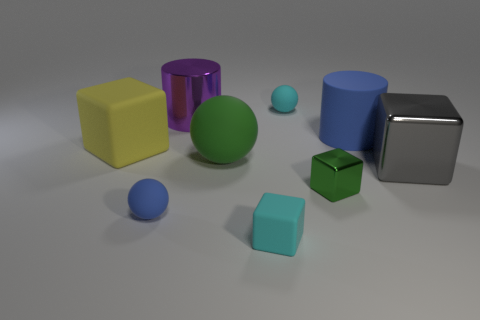There is a purple object that is the same size as the yellow matte object; what is it made of?
Your answer should be compact. Metal. Does the tiny green metal object have the same shape as the big yellow thing?
Make the answer very short. Yes. How many things are either tiny rubber spheres or small balls that are behind the green block?
Your answer should be very brief. 2. There is a block that is the same color as the large matte sphere; what is its material?
Your response must be concise. Metal. There is a cyan rubber object that is in front of the gray object; is its size the same as the large gray object?
Provide a succinct answer. No. There is a cyan rubber object in front of the large cube to the left of the big rubber cylinder; how many large yellow rubber cubes are behind it?
Provide a short and direct response. 1. What number of cyan objects are small matte objects or balls?
Offer a terse response. 2. The large cylinder that is made of the same material as the small blue ball is what color?
Your answer should be compact. Blue. What number of tiny things are yellow objects or blue shiny cylinders?
Make the answer very short. 0. Are there fewer cylinders than small gray matte things?
Give a very brief answer. No. 